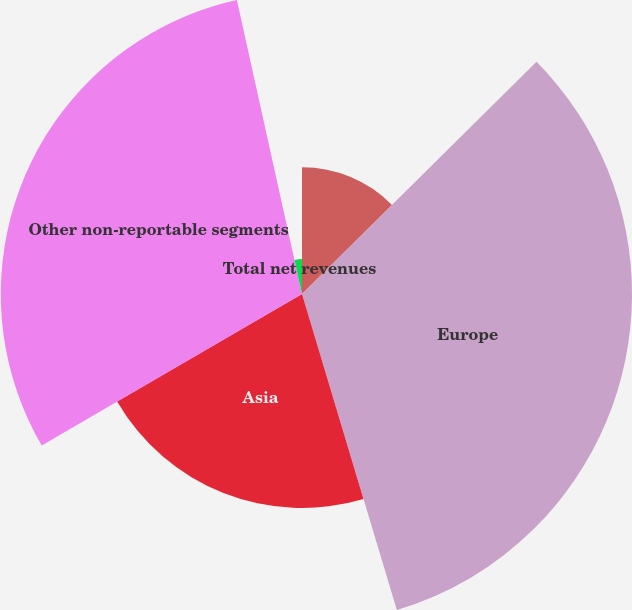<chart> <loc_0><loc_0><loc_500><loc_500><pie_chart><fcel>North America<fcel>Europe<fcel>Asia<fcel>Other non-reportable segments<fcel>Total net revenues<nl><fcel>12.58%<fcel>32.78%<fcel>21.25%<fcel>29.92%<fcel>3.47%<nl></chart> 